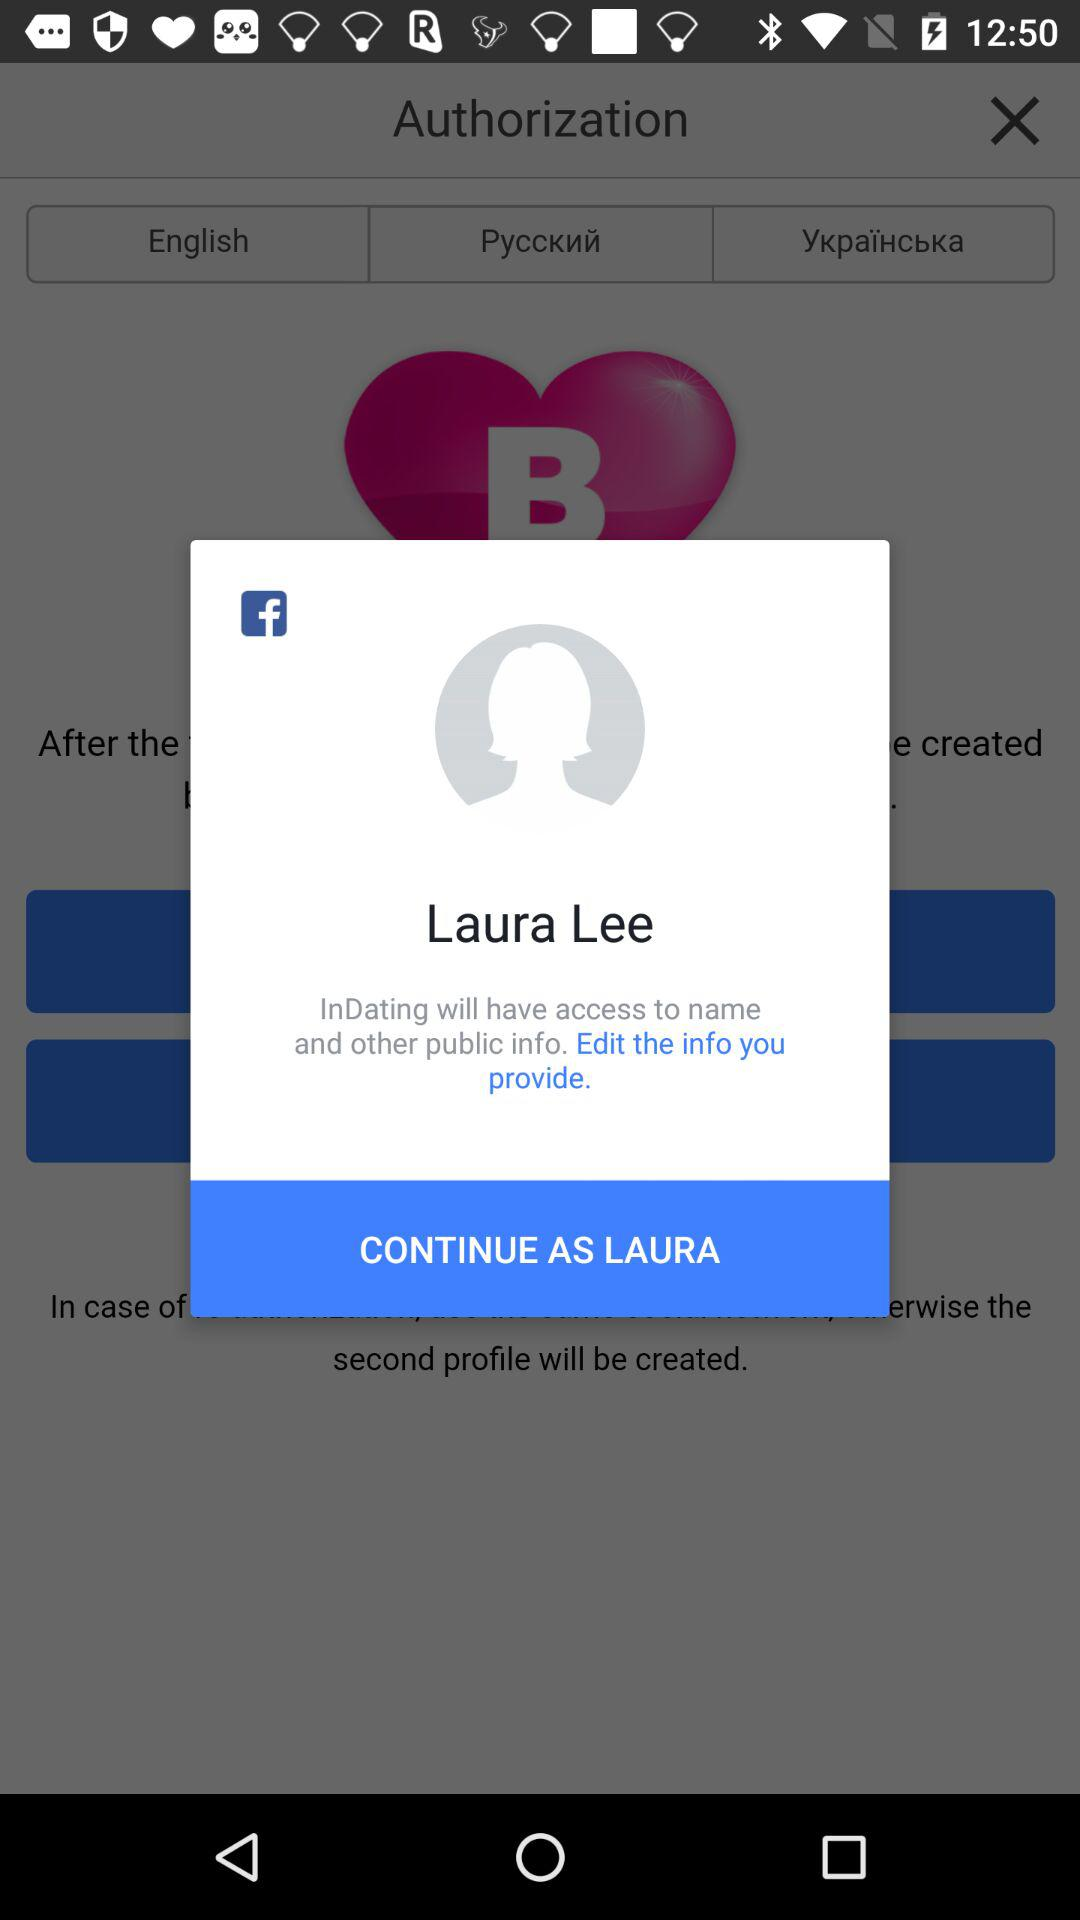What is the login name? The login name is Laura Lee. 